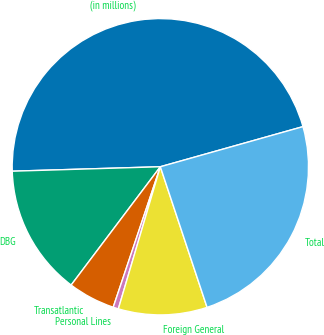Convert chart to OTSL. <chart><loc_0><loc_0><loc_500><loc_500><pie_chart><fcel>(in millions)<fcel>DBG<fcel>Transatlantic<fcel>Personal Lines<fcel>Foreign General<fcel>Total<nl><fcel>46.12%<fcel>14.24%<fcel>5.13%<fcel>0.58%<fcel>9.68%<fcel>24.26%<nl></chart> 